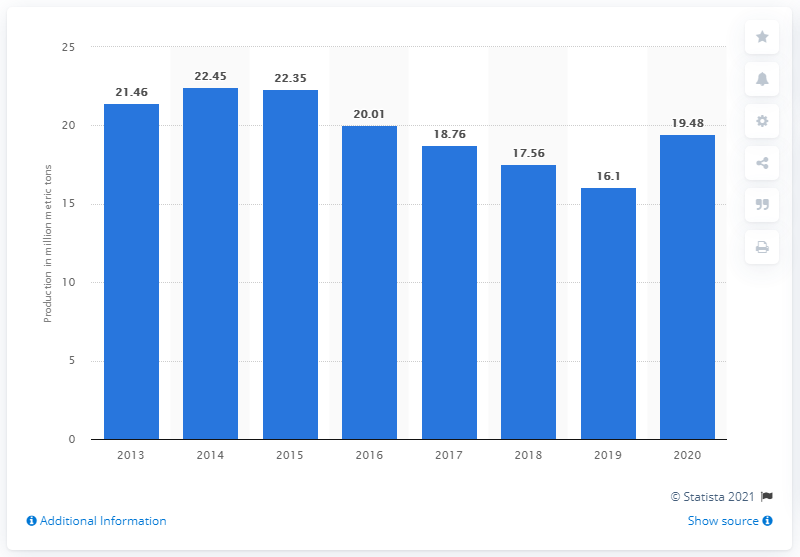Indicate a few pertinent items in this graphic. In 2020, a total of 19.48 million metric tons of cement was produced in Malaysia. 